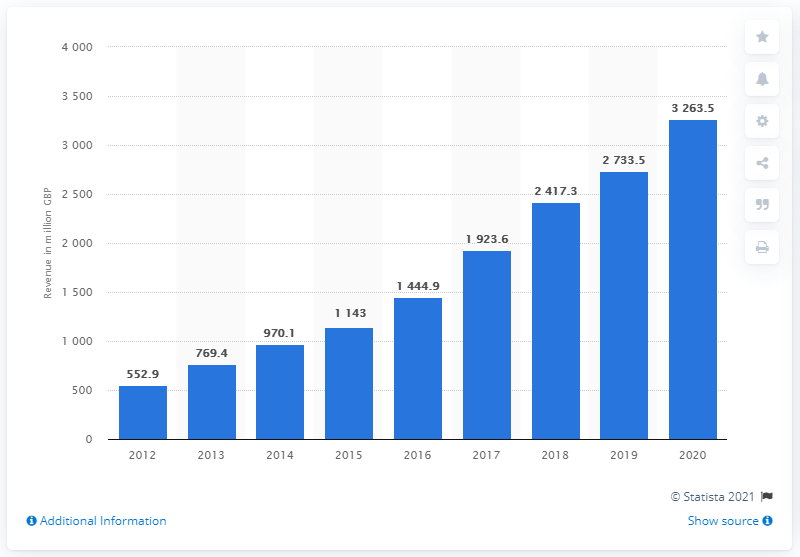List a handful of essential elements in this visual. Between 2012 and 2020, ASOS' worldwide revenue was approximately 3,263.5. 